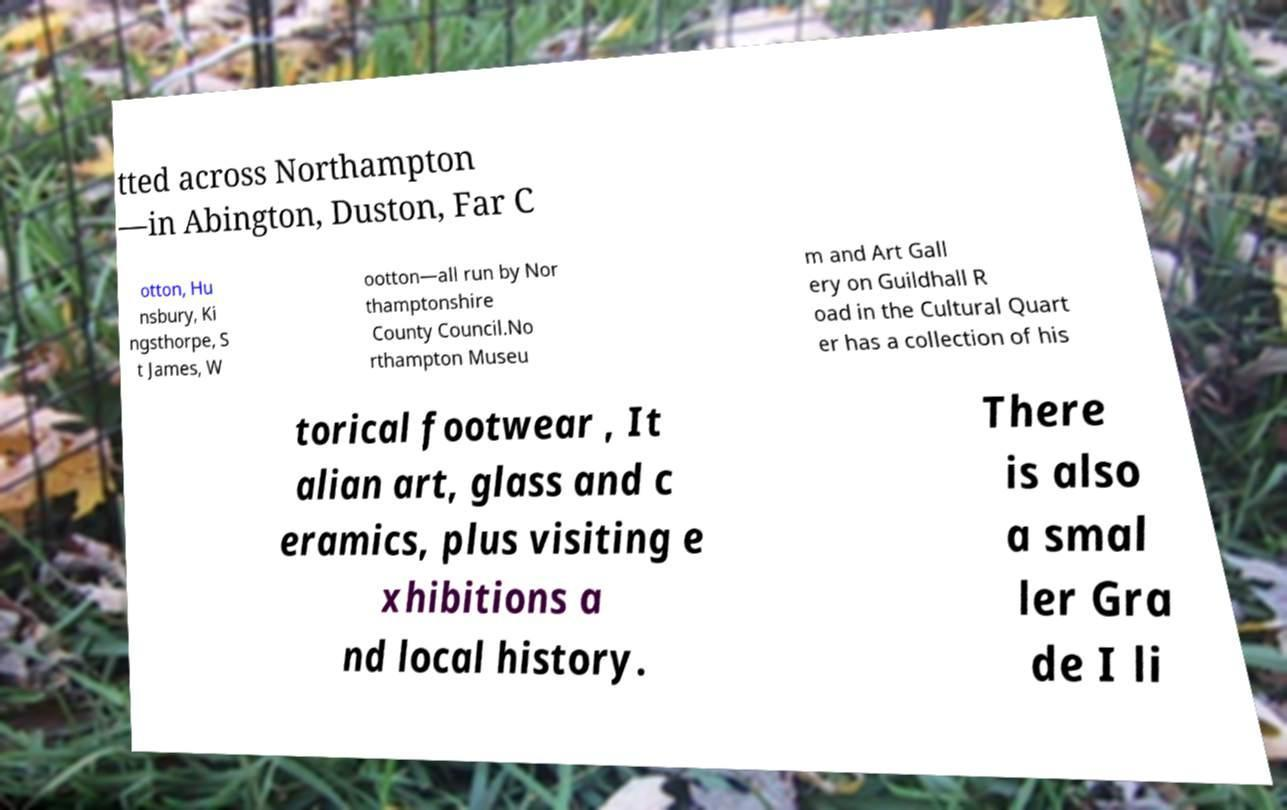Please read and relay the text visible in this image. What does it say? tted across Northampton —in Abington, Duston, Far C otton, Hu nsbury, Ki ngsthorpe, S t James, W ootton—all run by Nor thamptonshire County Council.No rthampton Museu m and Art Gall ery on Guildhall R oad in the Cultural Quart er has a collection of his torical footwear , It alian art, glass and c eramics, plus visiting e xhibitions a nd local history. There is also a smal ler Gra de I li 